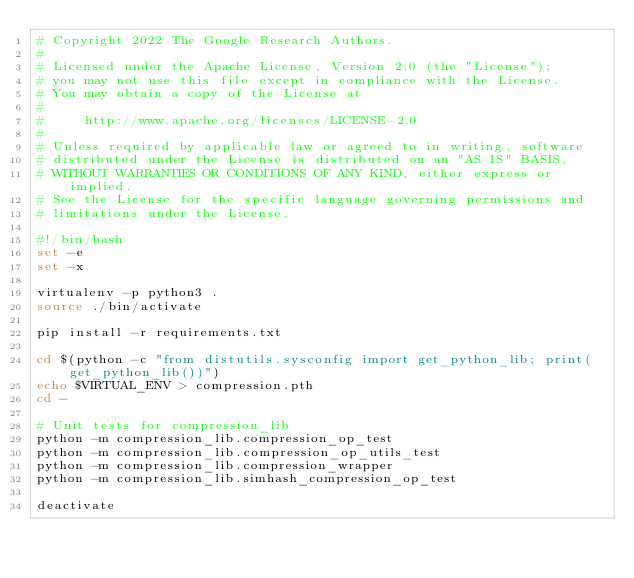Convert code to text. <code><loc_0><loc_0><loc_500><loc_500><_Bash_># Copyright 2022 The Google Research Authors.
#
# Licensed under the Apache License, Version 2.0 (the "License");
# you may not use this file except in compliance with the License.
# You may obtain a copy of the License at
#
#     http://www.apache.org/licenses/LICENSE-2.0
#
# Unless required by applicable law or agreed to in writing, software
# distributed under the License is distributed on an "AS IS" BASIS,
# WITHOUT WARRANTIES OR CONDITIONS OF ANY KIND, either express or implied.
# See the License for the specific language governing permissions and
# limitations under the License.

#!/bin/bash
set -e
set -x

virtualenv -p python3 .
source ./bin/activate

pip install -r requirements.txt

cd $(python -c "from distutils.sysconfig import get_python_lib; print(get_python_lib())")
echo $VIRTUAL_ENV > compression.pth
cd -

# Unit tests for compression_lib
python -m compression_lib.compression_op_test
python -m compression_lib.compression_op_utils_test
python -m compression_lib.compression_wrapper
python -m compression_lib.simhash_compression_op_test

deactivate
</code> 